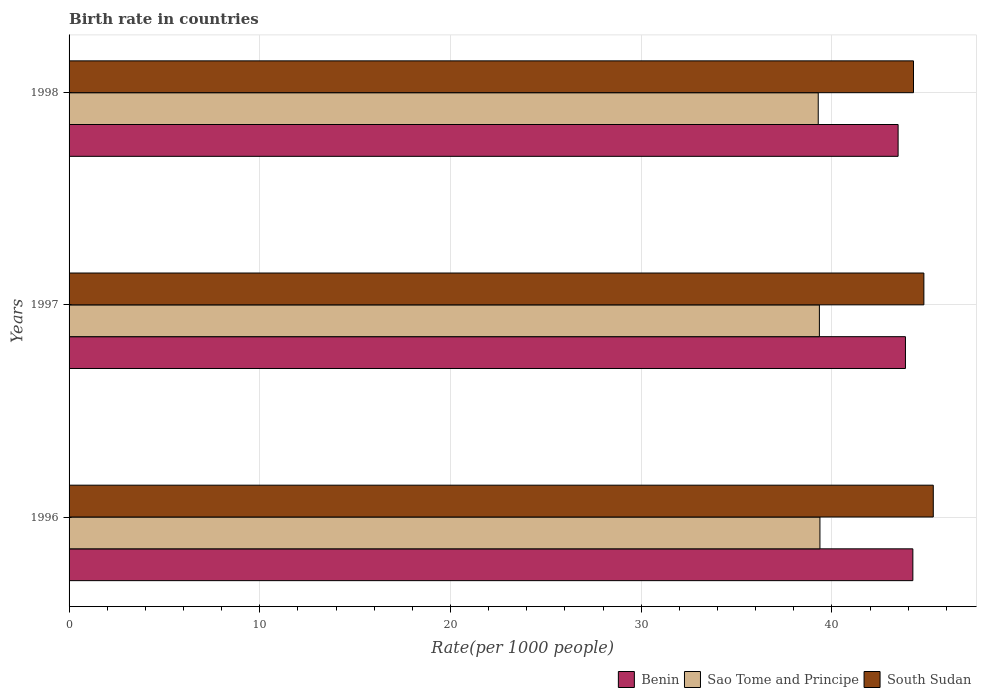How many different coloured bars are there?
Your answer should be very brief. 3. Are the number of bars per tick equal to the number of legend labels?
Make the answer very short. Yes. Are the number of bars on each tick of the Y-axis equal?
Provide a short and direct response. Yes. How many bars are there on the 2nd tick from the top?
Your answer should be very brief. 3. How many bars are there on the 3rd tick from the bottom?
Offer a very short reply. 3. What is the label of the 2nd group of bars from the top?
Provide a succinct answer. 1997. In how many cases, is the number of bars for a given year not equal to the number of legend labels?
Provide a short and direct response. 0. What is the birth rate in Benin in 1996?
Your answer should be very brief. 44.24. Across all years, what is the maximum birth rate in Sao Tome and Principe?
Ensure brevity in your answer.  39.37. Across all years, what is the minimum birth rate in South Sudan?
Offer a terse response. 44.28. What is the total birth rate in Sao Tome and Principe in the graph?
Your answer should be compact. 117.99. What is the difference between the birth rate in Benin in 1996 and that in 1998?
Your answer should be very brief. 0.77. What is the difference between the birth rate in Sao Tome and Principe in 1996 and the birth rate in Benin in 1998?
Your answer should be compact. -4.1. What is the average birth rate in Sao Tome and Principe per year?
Your response must be concise. 39.33. In the year 1998, what is the difference between the birth rate in Benin and birth rate in South Sudan?
Offer a very short reply. -0.81. In how many years, is the birth rate in Sao Tome and Principe greater than 22 ?
Offer a very short reply. 3. What is the ratio of the birth rate in South Sudan in 1996 to that in 1998?
Provide a succinct answer. 1.02. What is the difference between the highest and the second highest birth rate in Benin?
Offer a very short reply. 0.39. What is the difference between the highest and the lowest birth rate in Sao Tome and Principe?
Provide a short and direct response. 0.09. Is the sum of the birth rate in Sao Tome and Principe in 1997 and 1998 greater than the maximum birth rate in South Sudan across all years?
Give a very brief answer. Yes. What does the 3rd bar from the top in 1997 represents?
Ensure brevity in your answer.  Benin. What does the 3rd bar from the bottom in 1998 represents?
Your response must be concise. South Sudan. How many bars are there?
Give a very brief answer. 9. How many years are there in the graph?
Your answer should be very brief. 3. Does the graph contain grids?
Your answer should be very brief. Yes. Where does the legend appear in the graph?
Ensure brevity in your answer.  Bottom right. How many legend labels are there?
Keep it short and to the point. 3. How are the legend labels stacked?
Your answer should be compact. Horizontal. What is the title of the graph?
Your answer should be very brief. Birth rate in countries. What is the label or title of the X-axis?
Provide a succinct answer. Rate(per 1000 people). What is the Rate(per 1000 people) of Benin in 1996?
Your answer should be compact. 44.24. What is the Rate(per 1000 people) in Sao Tome and Principe in 1996?
Offer a very short reply. 39.37. What is the Rate(per 1000 people) in South Sudan in 1996?
Offer a very short reply. 45.31. What is the Rate(per 1000 people) of Benin in 1997?
Your answer should be very brief. 43.85. What is the Rate(per 1000 people) of Sao Tome and Principe in 1997?
Keep it short and to the point. 39.34. What is the Rate(per 1000 people) of South Sudan in 1997?
Ensure brevity in your answer.  44.82. What is the Rate(per 1000 people) of Benin in 1998?
Make the answer very short. 43.47. What is the Rate(per 1000 people) in Sao Tome and Principe in 1998?
Make the answer very short. 39.28. What is the Rate(per 1000 people) of South Sudan in 1998?
Offer a very short reply. 44.28. Across all years, what is the maximum Rate(per 1000 people) of Benin?
Give a very brief answer. 44.24. Across all years, what is the maximum Rate(per 1000 people) of Sao Tome and Principe?
Make the answer very short. 39.37. Across all years, what is the maximum Rate(per 1000 people) of South Sudan?
Your response must be concise. 45.31. Across all years, what is the minimum Rate(per 1000 people) in Benin?
Provide a short and direct response. 43.47. Across all years, what is the minimum Rate(per 1000 people) of Sao Tome and Principe?
Give a very brief answer. 39.28. Across all years, what is the minimum Rate(per 1000 people) in South Sudan?
Keep it short and to the point. 44.28. What is the total Rate(per 1000 people) of Benin in the graph?
Offer a terse response. 131.56. What is the total Rate(per 1000 people) of Sao Tome and Principe in the graph?
Your answer should be compact. 117.99. What is the total Rate(per 1000 people) in South Sudan in the graph?
Ensure brevity in your answer.  134.41. What is the difference between the Rate(per 1000 people) in Benin in 1996 and that in 1997?
Provide a succinct answer. 0.39. What is the difference between the Rate(per 1000 people) of Sao Tome and Principe in 1996 and that in 1997?
Give a very brief answer. 0.03. What is the difference between the Rate(per 1000 people) of South Sudan in 1996 and that in 1997?
Offer a terse response. 0.49. What is the difference between the Rate(per 1000 people) of Benin in 1996 and that in 1998?
Ensure brevity in your answer.  0.77. What is the difference between the Rate(per 1000 people) of Sao Tome and Principe in 1996 and that in 1998?
Offer a very short reply. 0.09. What is the difference between the Rate(per 1000 people) in Benin in 1997 and that in 1998?
Provide a short and direct response. 0.39. What is the difference between the Rate(per 1000 people) in South Sudan in 1997 and that in 1998?
Keep it short and to the point. 0.54. What is the difference between the Rate(per 1000 people) in Benin in 1996 and the Rate(per 1000 people) in Sao Tome and Principe in 1997?
Give a very brief answer. 4.9. What is the difference between the Rate(per 1000 people) in Benin in 1996 and the Rate(per 1000 people) in South Sudan in 1997?
Provide a succinct answer. -0.58. What is the difference between the Rate(per 1000 people) of Sao Tome and Principe in 1996 and the Rate(per 1000 people) of South Sudan in 1997?
Offer a terse response. -5.45. What is the difference between the Rate(per 1000 people) in Benin in 1996 and the Rate(per 1000 people) in Sao Tome and Principe in 1998?
Provide a short and direct response. 4.96. What is the difference between the Rate(per 1000 people) in Benin in 1996 and the Rate(per 1000 people) in South Sudan in 1998?
Provide a short and direct response. -0.03. What is the difference between the Rate(per 1000 people) of Sao Tome and Principe in 1996 and the Rate(per 1000 people) of South Sudan in 1998?
Provide a succinct answer. -4.91. What is the difference between the Rate(per 1000 people) of Benin in 1997 and the Rate(per 1000 people) of Sao Tome and Principe in 1998?
Provide a short and direct response. 4.57. What is the difference between the Rate(per 1000 people) in Benin in 1997 and the Rate(per 1000 people) in South Sudan in 1998?
Offer a terse response. -0.42. What is the difference between the Rate(per 1000 people) of Sao Tome and Principe in 1997 and the Rate(per 1000 people) of South Sudan in 1998?
Provide a succinct answer. -4.93. What is the average Rate(per 1000 people) in Benin per year?
Keep it short and to the point. 43.85. What is the average Rate(per 1000 people) of Sao Tome and Principe per year?
Make the answer very short. 39.33. What is the average Rate(per 1000 people) in South Sudan per year?
Offer a terse response. 44.8. In the year 1996, what is the difference between the Rate(per 1000 people) of Benin and Rate(per 1000 people) of Sao Tome and Principe?
Offer a very short reply. 4.87. In the year 1996, what is the difference between the Rate(per 1000 people) in Benin and Rate(per 1000 people) in South Sudan?
Offer a very short reply. -1.07. In the year 1996, what is the difference between the Rate(per 1000 people) in Sao Tome and Principe and Rate(per 1000 people) in South Sudan?
Offer a terse response. -5.94. In the year 1997, what is the difference between the Rate(per 1000 people) in Benin and Rate(per 1000 people) in Sao Tome and Principe?
Give a very brief answer. 4.51. In the year 1997, what is the difference between the Rate(per 1000 people) of Benin and Rate(per 1000 people) of South Sudan?
Give a very brief answer. -0.97. In the year 1997, what is the difference between the Rate(per 1000 people) of Sao Tome and Principe and Rate(per 1000 people) of South Sudan?
Give a very brief answer. -5.48. In the year 1998, what is the difference between the Rate(per 1000 people) in Benin and Rate(per 1000 people) in Sao Tome and Principe?
Give a very brief answer. 4.19. In the year 1998, what is the difference between the Rate(per 1000 people) in Benin and Rate(per 1000 people) in South Sudan?
Provide a short and direct response. -0.81. In the year 1998, what is the difference between the Rate(per 1000 people) in Sao Tome and Principe and Rate(per 1000 people) in South Sudan?
Your answer should be very brief. -5. What is the ratio of the Rate(per 1000 people) of Benin in 1996 to that in 1997?
Ensure brevity in your answer.  1.01. What is the ratio of the Rate(per 1000 people) of South Sudan in 1996 to that in 1997?
Keep it short and to the point. 1.01. What is the ratio of the Rate(per 1000 people) in Benin in 1996 to that in 1998?
Your answer should be very brief. 1.02. What is the ratio of the Rate(per 1000 people) of South Sudan in 1996 to that in 1998?
Your answer should be very brief. 1.02. What is the ratio of the Rate(per 1000 people) of Benin in 1997 to that in 1998?
Provide a succinct answer. 1.01. What is the ratio of the Rate(per 1000 people) in Sao Tome and Principe in 1997 to that in 1998?
Offer a very short reply. 1. What is the ratio of the Rate(per 1000 people) of South Sudan in 1997 to that in 1998?
Your answer should be compact. 1.01. What is the difference between the highest and the second highest Rate(per 1000 people) of Benin?
Keep it short and to the point. 0.39. What is the difference between the highest and the second highest Rate(per 1000 people) of Sao Tome and Principe?
Your answer should be compact. 0.03. What is the difference between the highest and the second highest Rate(per 1000 people) of South Sudan?
Offer a terse response. 0.49. What is the difference between the highest and the lowest Rate(per 1000 people) of Benin?
Offer a terse response. 0.77. What is the difference between the highest and the lowest Rate(per 1000 people) in Sao Tome and Principe?
Your answer should be very brief. 0.09. 